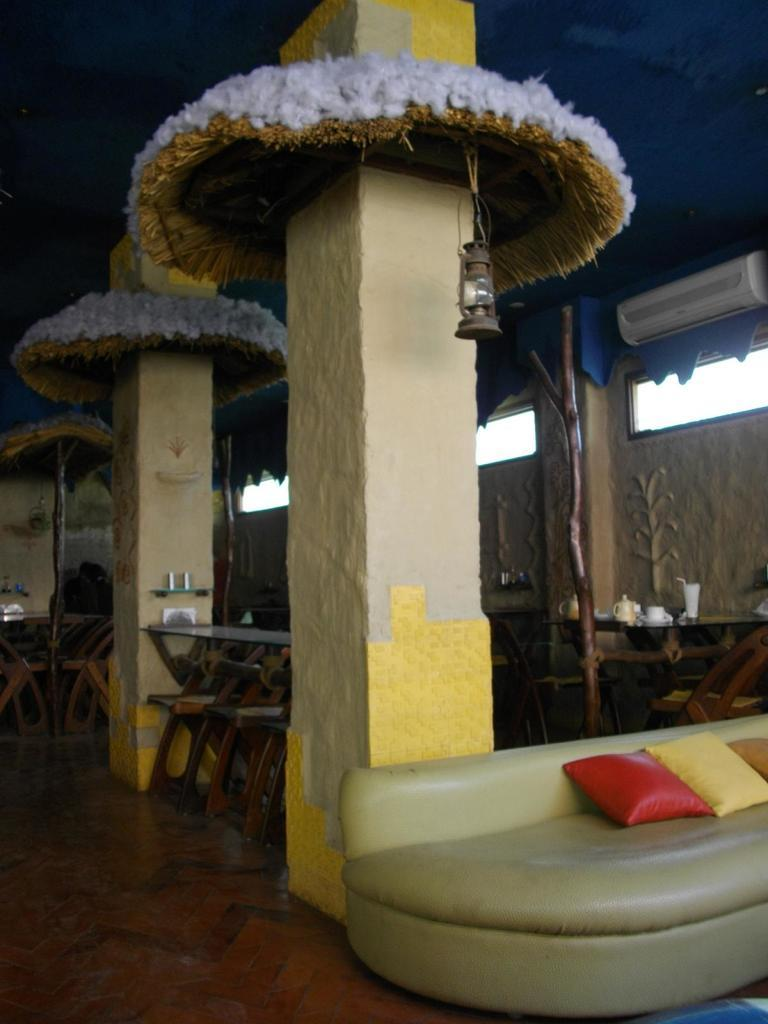What type of furniture is in the image? There is a sofa, chairs, and a table in the image. What can be found on the sofa? There are pillows on the sofa. What is the source of light in the image? There is a lamp in the image. What architectural feature is present in the image? There is a pillar in the image. What type of sack is being used to destroy the pillar in the image? There is no sack or destruction present in the image. 